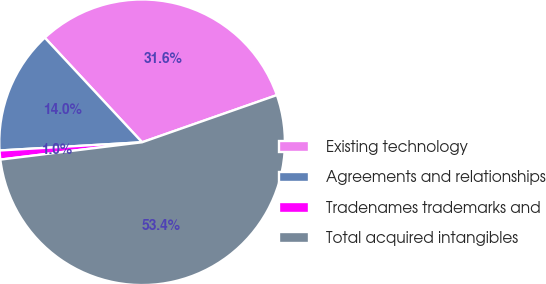Convert chart. <chart><loc_0><loc_0><loc_500><loc_500><pie_chart><fcel>Existing technology<fcel>Agreements and relationships<fcel>Tradenames trademarks and<fcel>Total acquired intangibles<nl><fcel>31.57%<fcel>13.99%<fcel>1.02%<fcel>53.42%<nl></chart> 